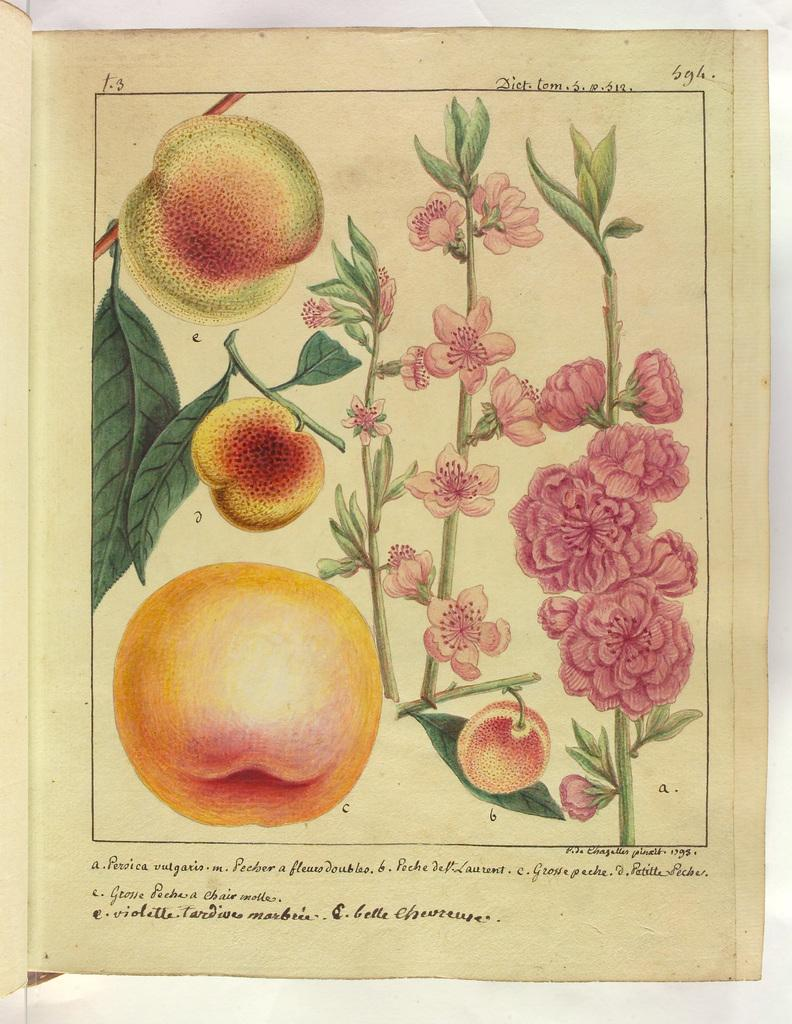What is the main subject of the drawing in the image? There is an apple drawn in the image. What is attached to the apple in the drawing? There is a stem in the image. What other elements are present in the drawing? There are leaves and flowers in the image. Is there any text or writing in the image? Yes, there is content written in the image. What type of structure can be seen in the background of the image? There is no structure visible in the image; it features a drawing of an apple with leaves, a stem, flowers, and written content. 